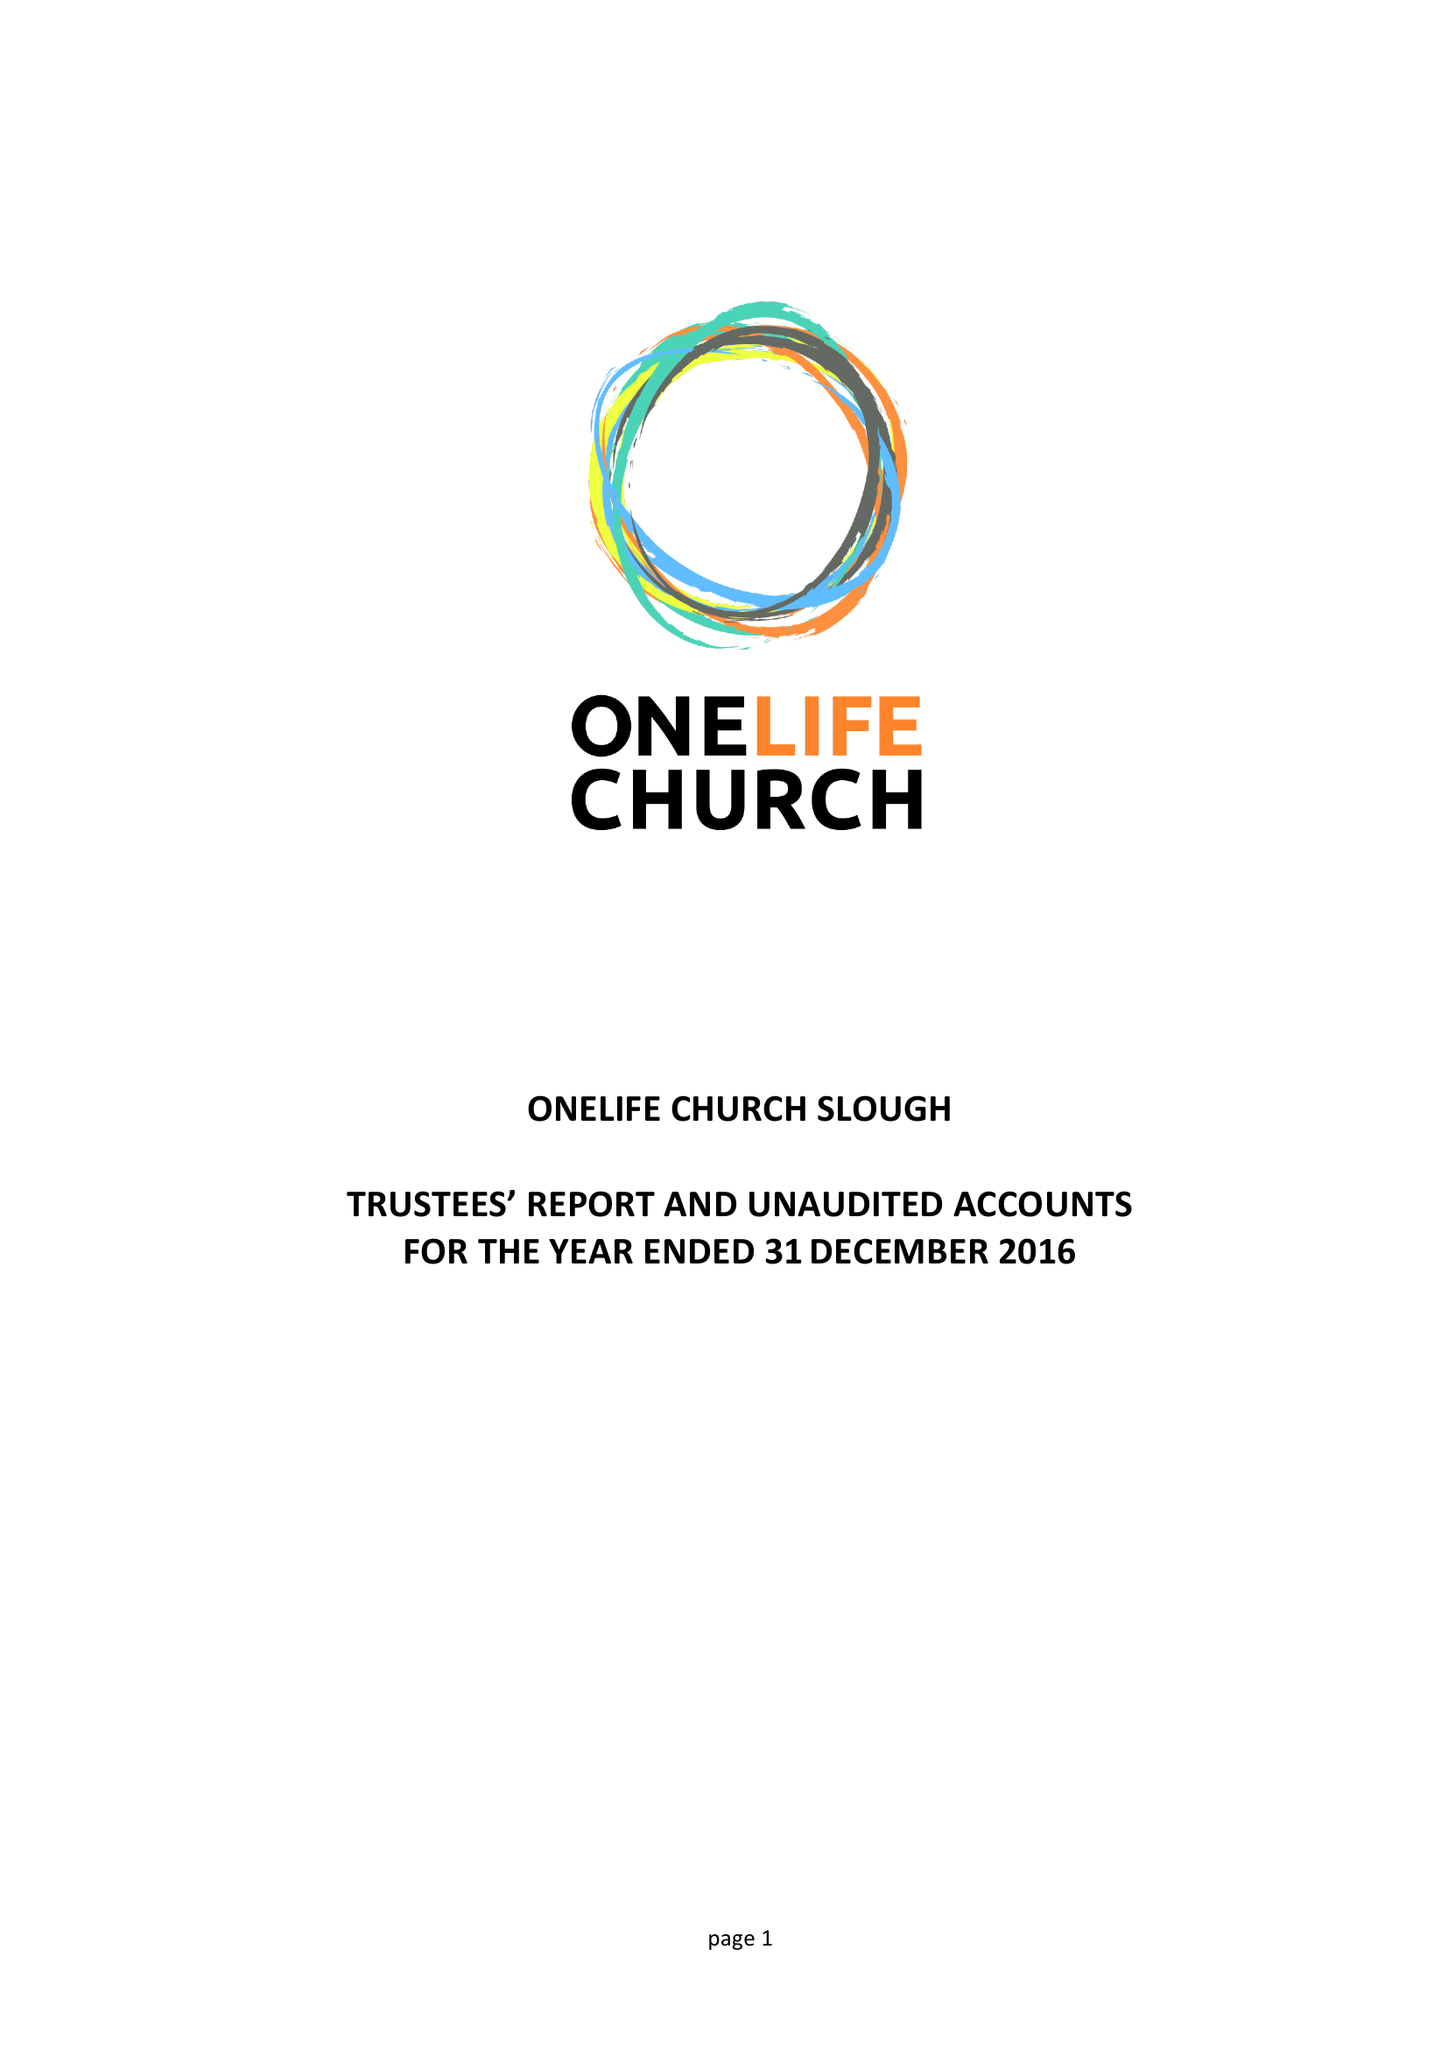What is the value for the address__post_town?
Answer the question using a single word or phrase. SLOUGH 